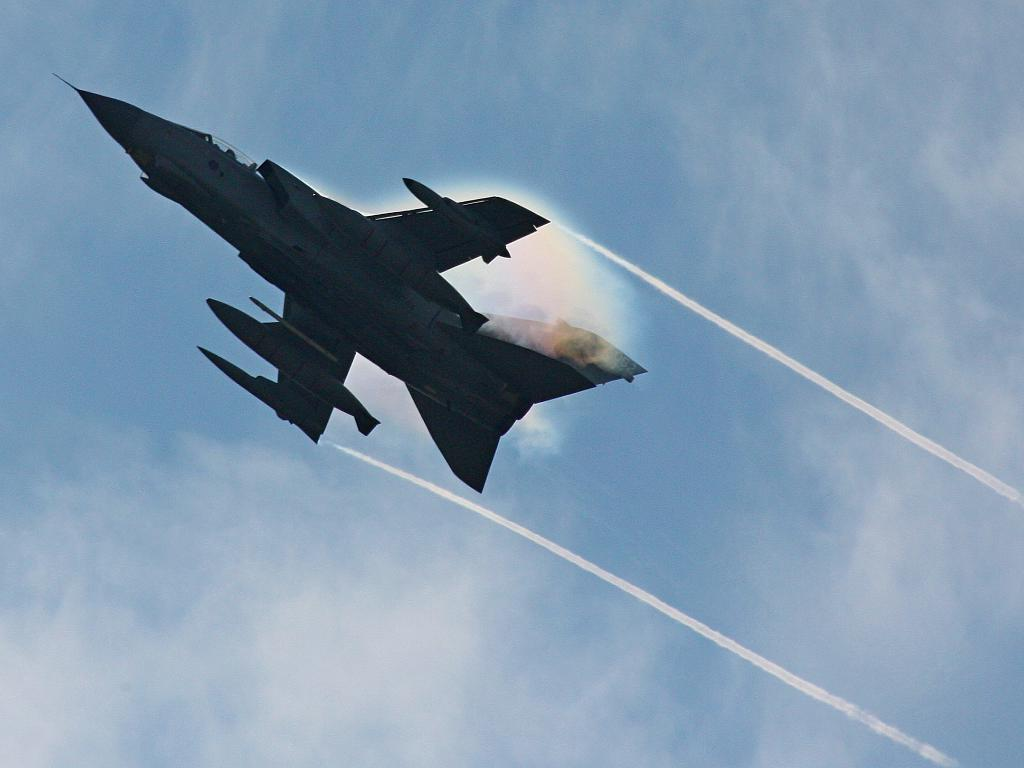Where was the picture taken? The picture was clicked outside. What can be seen in the sky in the image? There is a Jet aircraft in the sky, and there is smoke in the sky. What is the Jet aircraft doing in the image? The Jet aircraft is flying in the sky. What advice does the grandfather give to the judge in the image? There is no grandfather or judge present in the image; it features a Jet aircraft flying in the sky with smoke. 